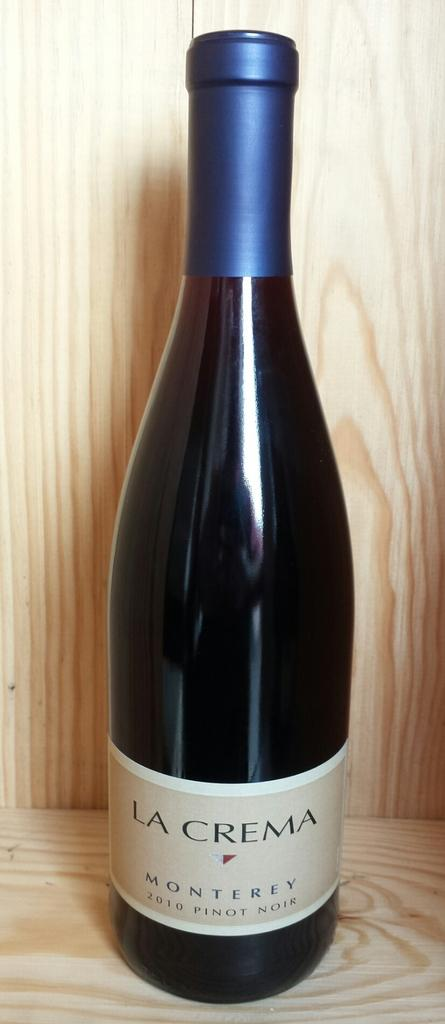What is present on the wooden surface in the image? There is a bottle on the wooden surface in the image. What is the material of the object behind the bottle? The object behind the bottle is made of wood. What can be found on the bottle in the image? The bottle has a label with text on it. How does the bottle attack the wooden object in the image? The bottle does not attack the wooden object in the image; it is a still image with no action taking place. 